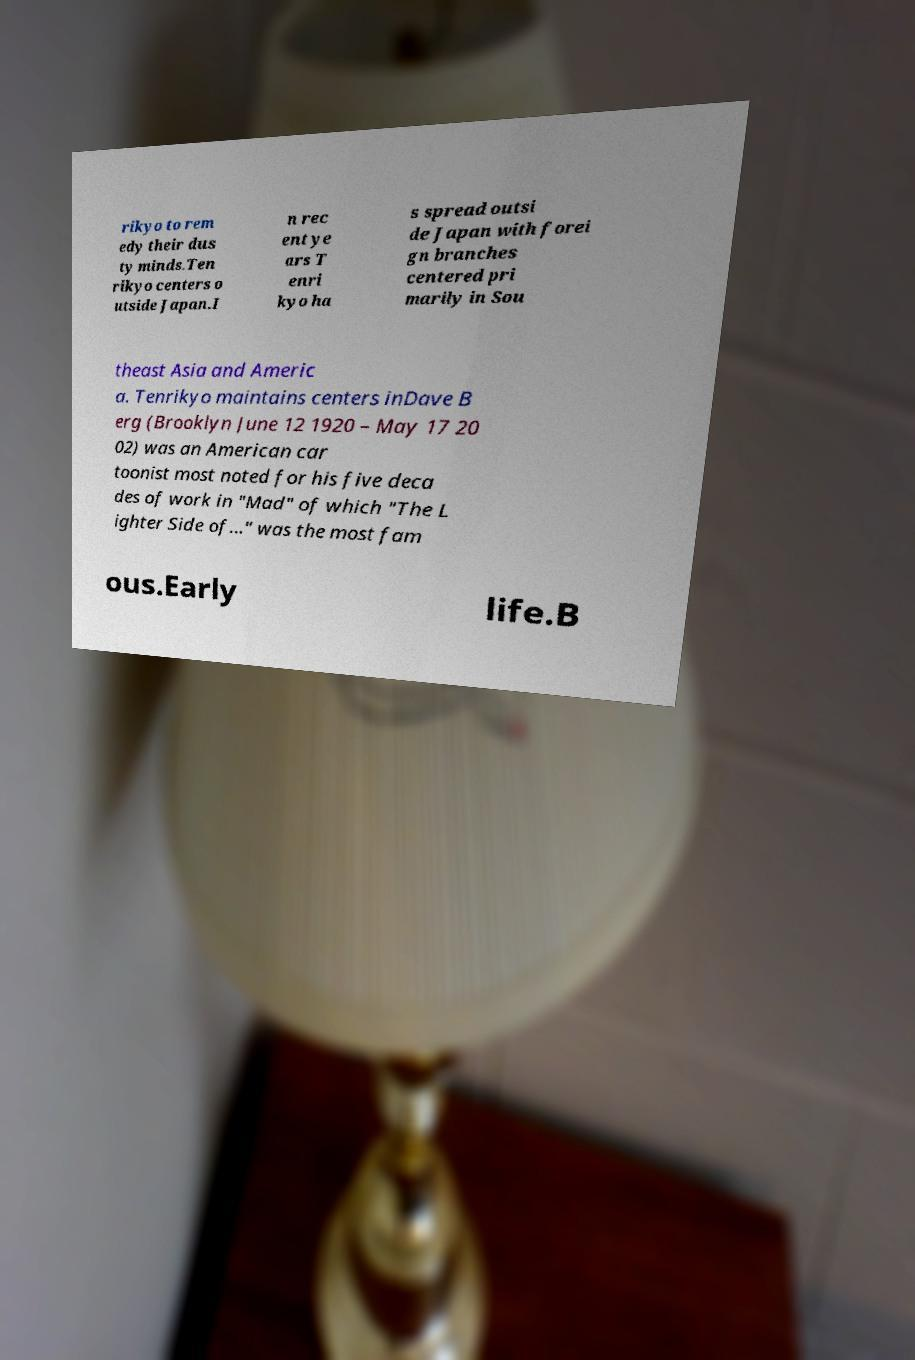Could you extract and type out the text from this image? rikyo to rem edy their dus ty minds.Ten rikyo centers o utside Japan.I n rec ent ye ars T enri kyo ha s spread outsi de Japan with forei gn branches centered pri marily in Sou theast Asia and Americ a. Tenrikyo maintains centers inDave B erg (Brooklyn June 12 1920 – May 17 20 02) was an American car toonist most noted for his five deca des of work in "Mad" of which "The L ighter Side of..." was the most fam ous.Early life.B 